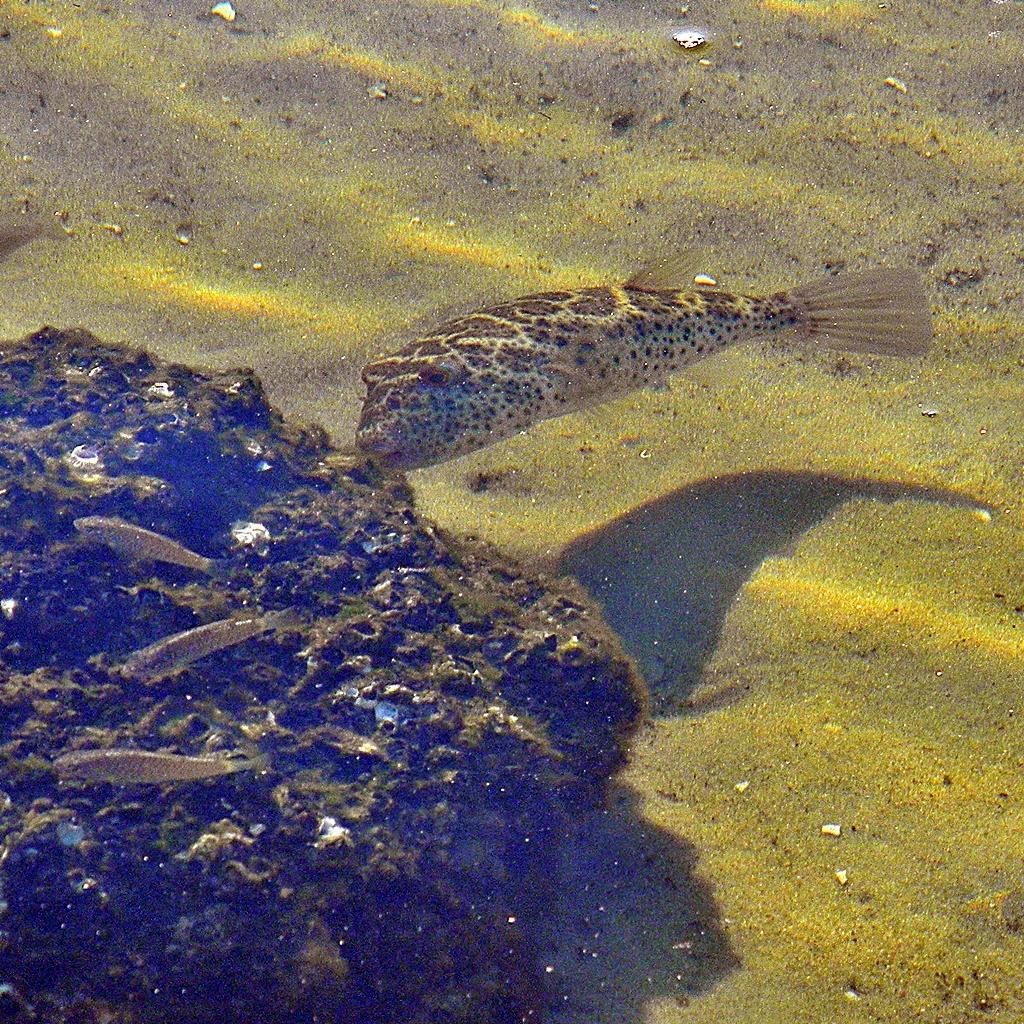In one or two sentences, can you explain what this image depicts? In this picture there are fishes in the water. At the bottom there is sand and there are plants. 